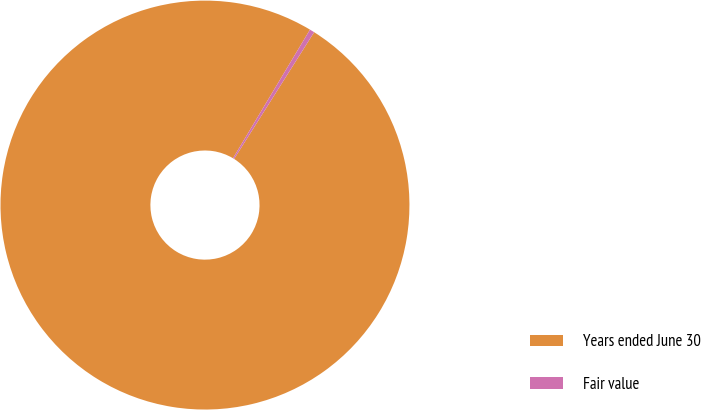Convert chart. <chart><loc_0><loc_0><loc_500><loc_500><pie_chart><fcel>Years ended June 30<fcel>Fair value<nl><fcel>99.62%<fcel>0.38%<nl></chart> 